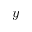Convert formula to latex. <formula><loc_0><loc_0><loc_500><loc_500>y</formula> 